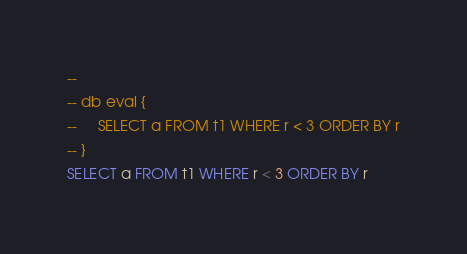<code> <loc_0><loc_0><loc_500><loc_500><_SQL_>-- 
-- db eval {
--     SELECT a FROM t1 WHERE r < 3 ORDER BY r
-- }
SELECT a FROM t1 WHERE r < 3 ORDER BY r</code> 